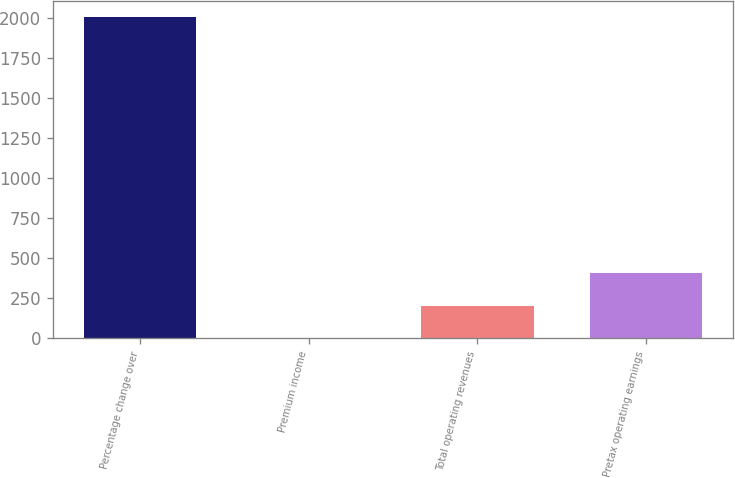Convert chart to OTSL. <chart><loc_0><loc_0><loc_500><loc_500><bar_chart><fcel>Percentage change over<fcel>Premium income<fcel>Total operating revenues<fcel>Pretax operating earnings<nl><fcel>2007<fcel>4.3<fcel>204.57<fcel>404.84<nl></chart> 